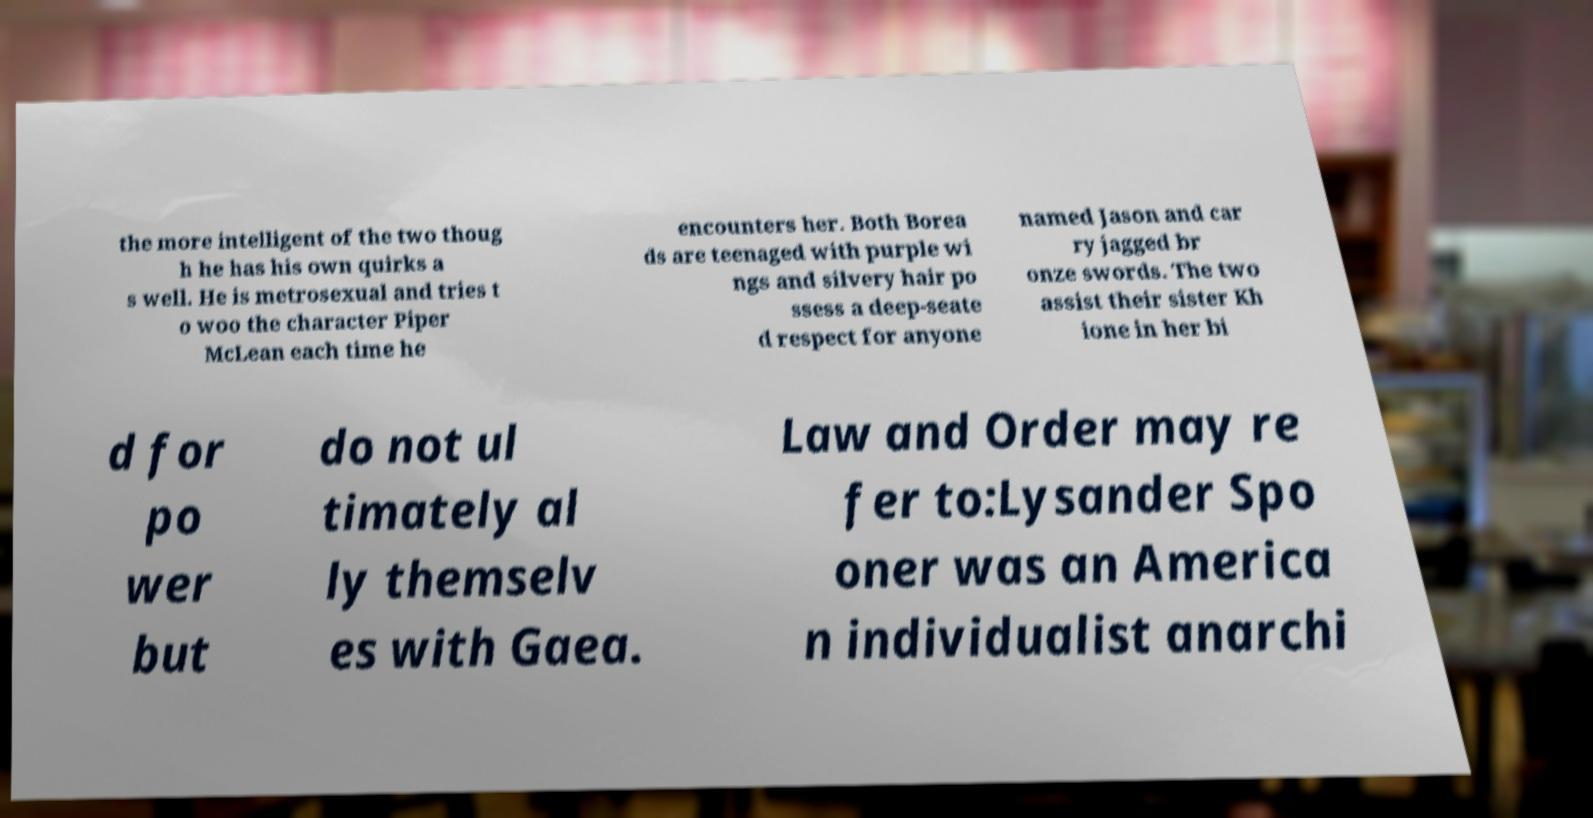Please read and relay the text visible in this image. What does it say? the more intelligent of the two thoug h he has his own quirks a s well. He is metrosexual and tries t o woo the character Piper McLean each time he encounters her. Both Borea ds are teenaged with purple wi ngs and silvery hair po ssess a deep-seate d respect for anyone named Jason and car ry jagged br onze swords. The two assist their sister Kh ione in her bi d for po wer but do not ul timately al ly themselv es with Gaea. Law and Order may re fer to:Lysander Spo oner was an America n individualist anarchi 